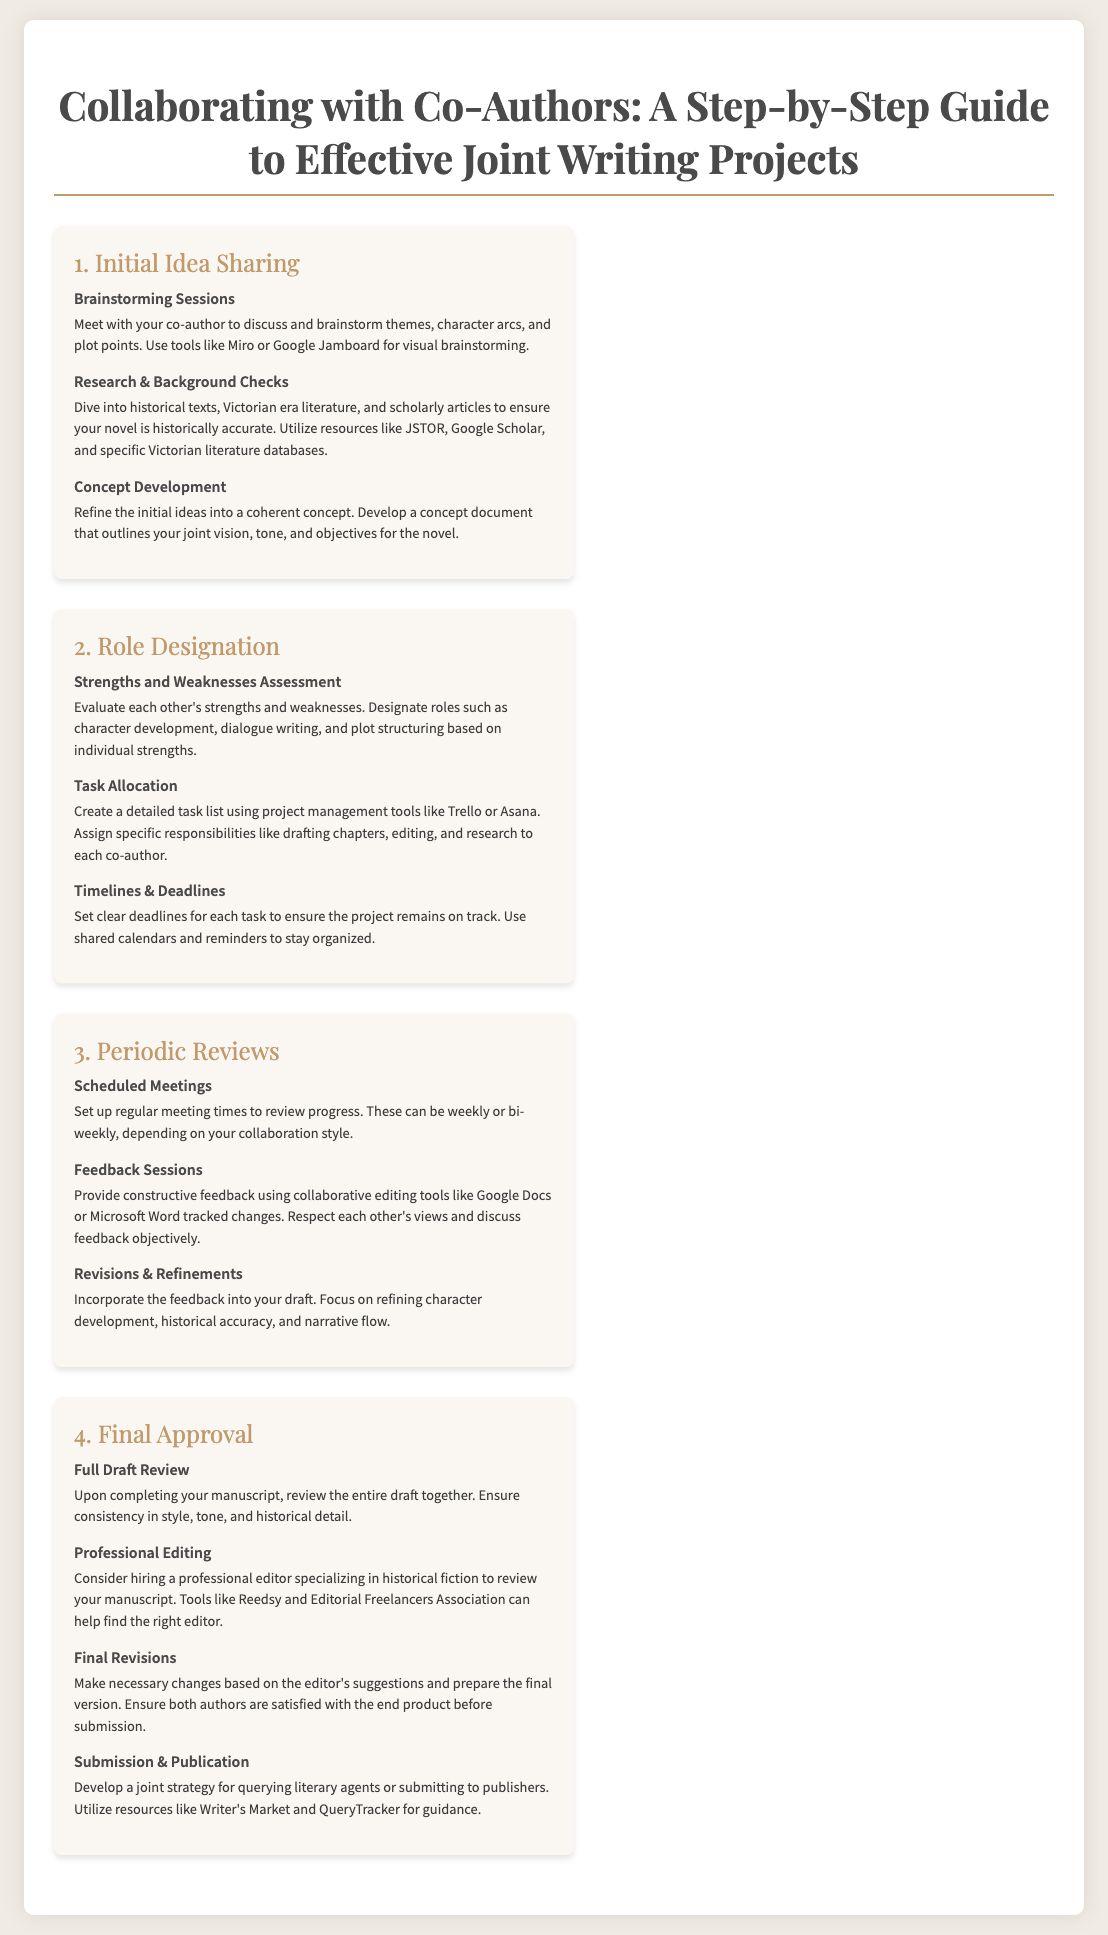what is the first step in the collaboration process? The first step is Initial Idea Sharing, which encompasses brainstorming sessions, research, and concept development.
Answer: Initial Idea Sharing name one tool suggested for brainstorming sessions. The document suggests using tools like Miro or Google Jamboard for visual brainstorming.
Answer: Miro or Google Jamboard how many main stages are outlined in the guide? The document outlines four main stages in the collaboration process, from idea sharing to final approval.
Answer: Four what is evaluated during the Role Designation stage? The strengths and weaknesses of each co-author are evaluated to assign specific roles in the writing process.
Answer: Strengths and weaknesses what should co-authors do during the Full Draft Review? Co-authors should review the entire draft together to ensure consistency in style, tone, and historical detail.
Answer: Review the entire draft together list one resource mentioned for finding professional editors. The document mentions tools like Reedsy and the Editorial Freelancers Association to find editors.
Answer: Reedsy or Editorial Freelancers Association what is the purpose of Scheduled Meetings in the Periodic Reviews stage? The purpose is to set up regular check-ins to review progress, which can be weekly or bi-weekly.
Answer: Review progress what is the last step in the collaboration process? The last step is Submission & Publication, where a joint strategy for querying agents or submitting to publishers is developed.
Answer: Submission & Publication 